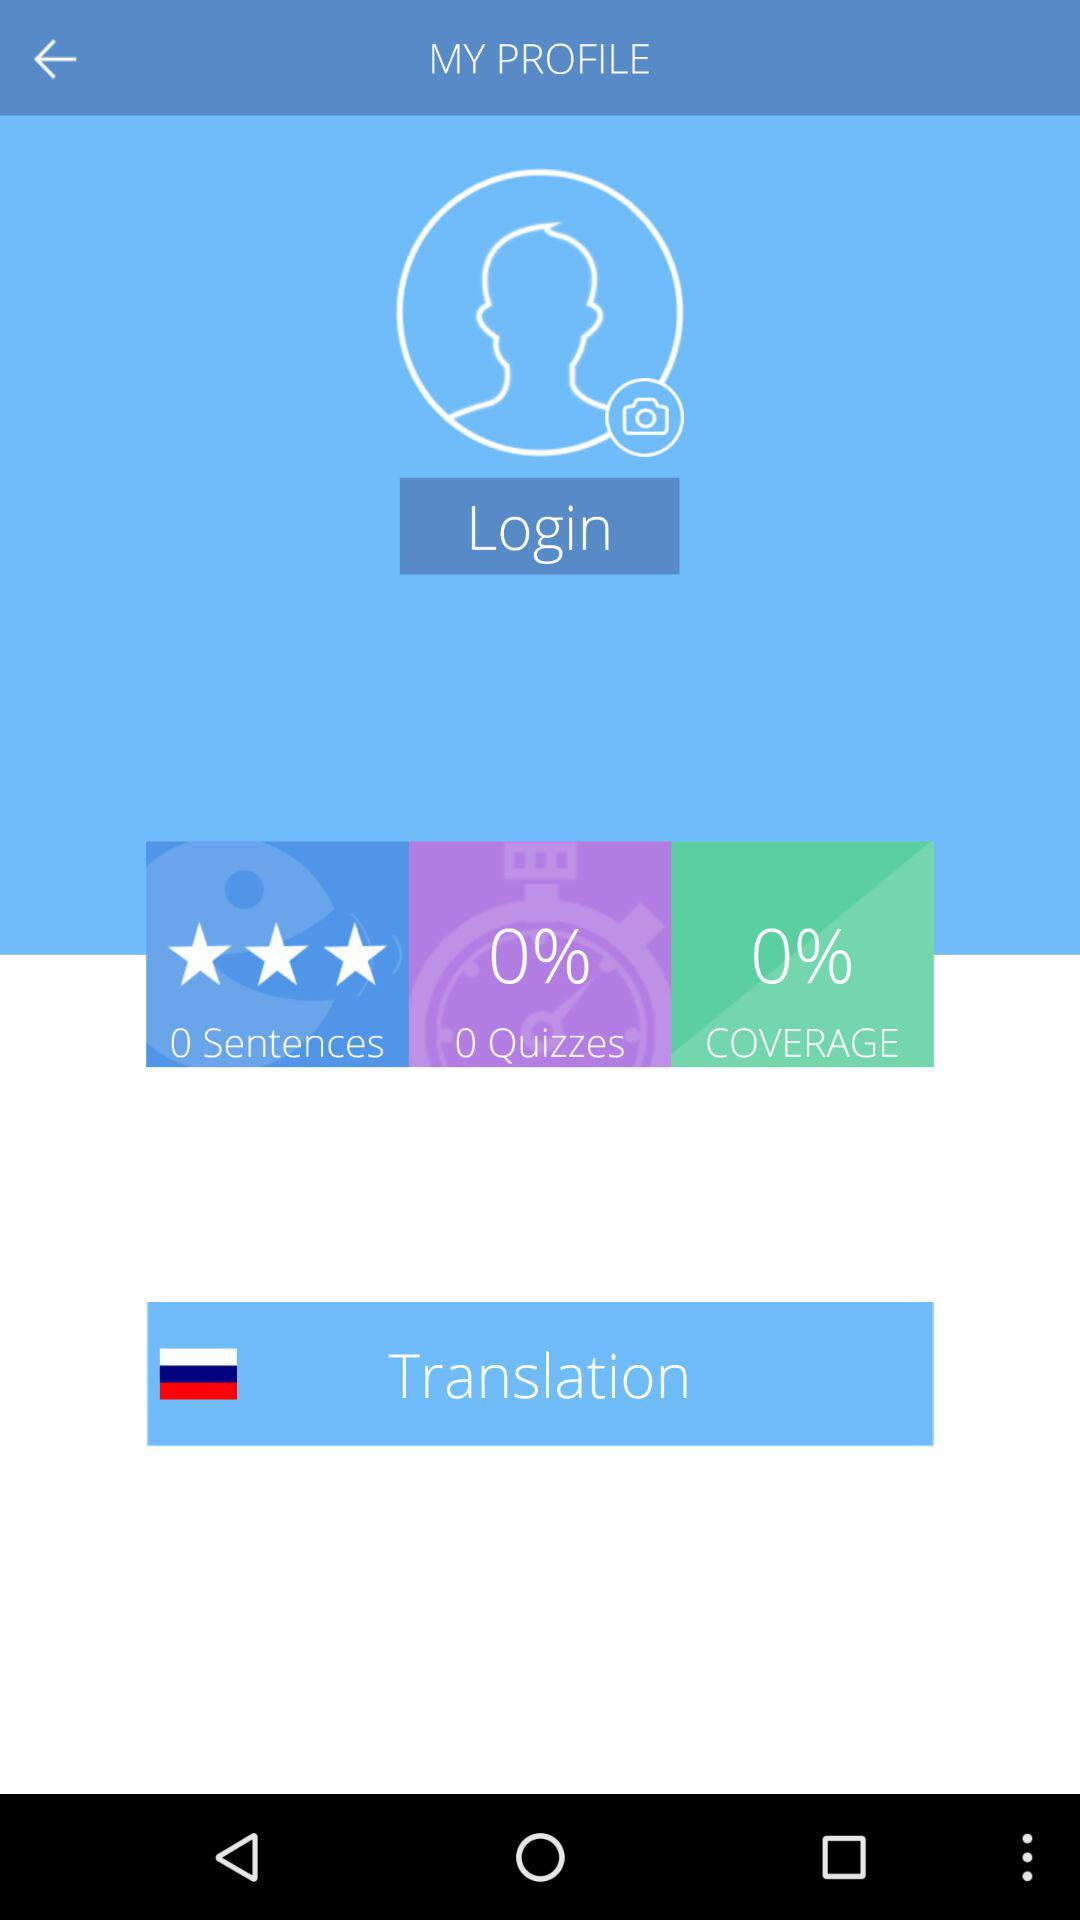What is the number of quizzes? The number of quizzes is 0. 